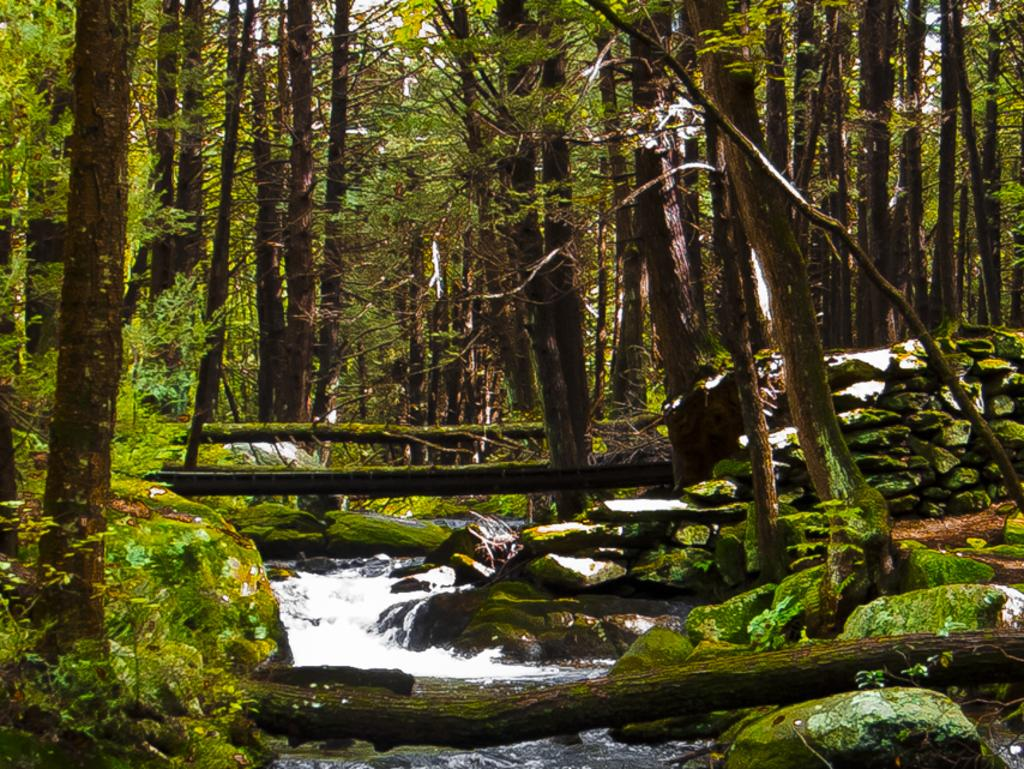What type of vegetation is present in the image? There are many trees and few plants in the image. Can you describe the presence of algae in the image? Yes, algae is visible on a rock in the image. What else can be seen in the image besides vegetation? There is water visible in the image. What type of pan is being used to cook the things in the image? There is no pan or cooking activity present in the image. How many bubbles can be seen in the image? There are no bubbles visible in the image. 